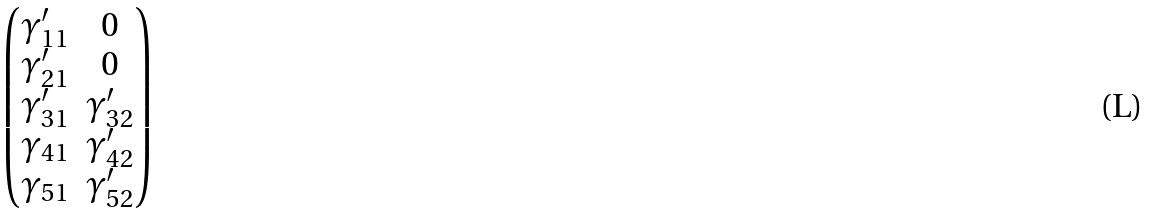<formula> <loc_0><loc_0><loc_500><loc_500>\begin{pmatrix} \gamma _ { 1 1 } ^ { \prime } & 0 \\ \gamma _ { 2 1 } ^ { \prime } & 0 \\ \gamma _ { 3 1 } ^ { \prime } & \gamma _ { 3 2 } ^ { \prime } \\ \gamma _ { 4 1 } & \gamma _ { 4 2 } ^ { \prime } \\ \gamma _ { 5 1 } & \gamma _ { 5 2 } ^ { \prime } \end{pmatrix}</formula> 